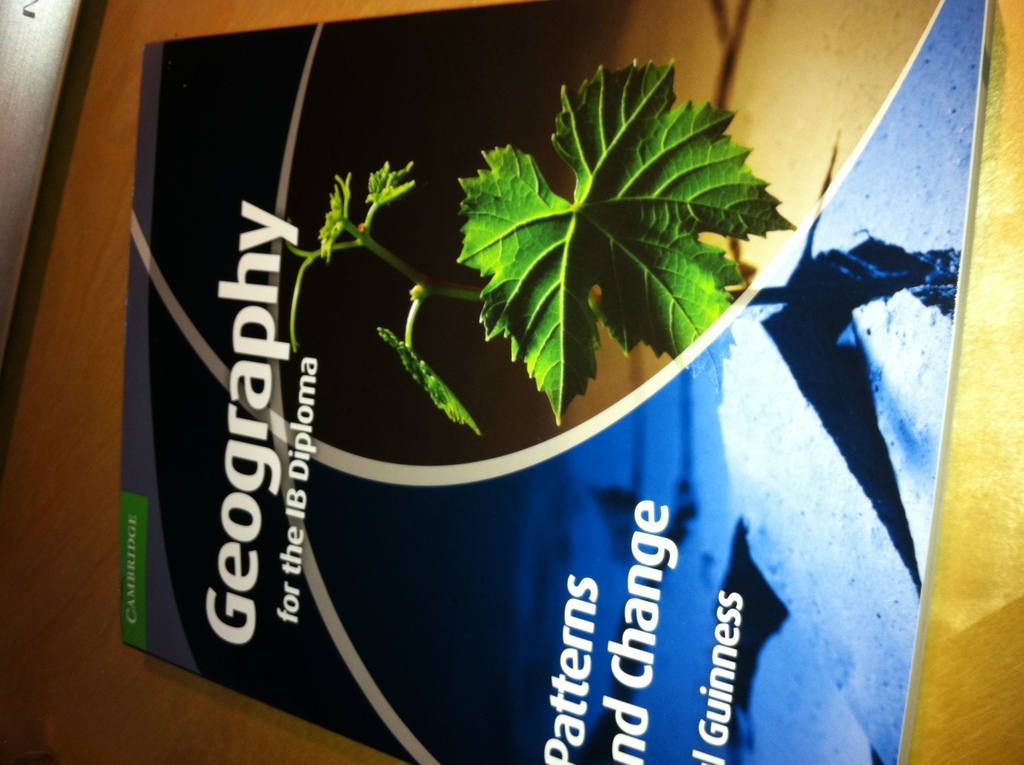What does the leaf symbolize in the context of a geography textbook? The leaf likely symbolizes the connection between natural environments and geographical studies, emphasizing the importance of understanding ecological patterns and their impact on the earth's surface. 